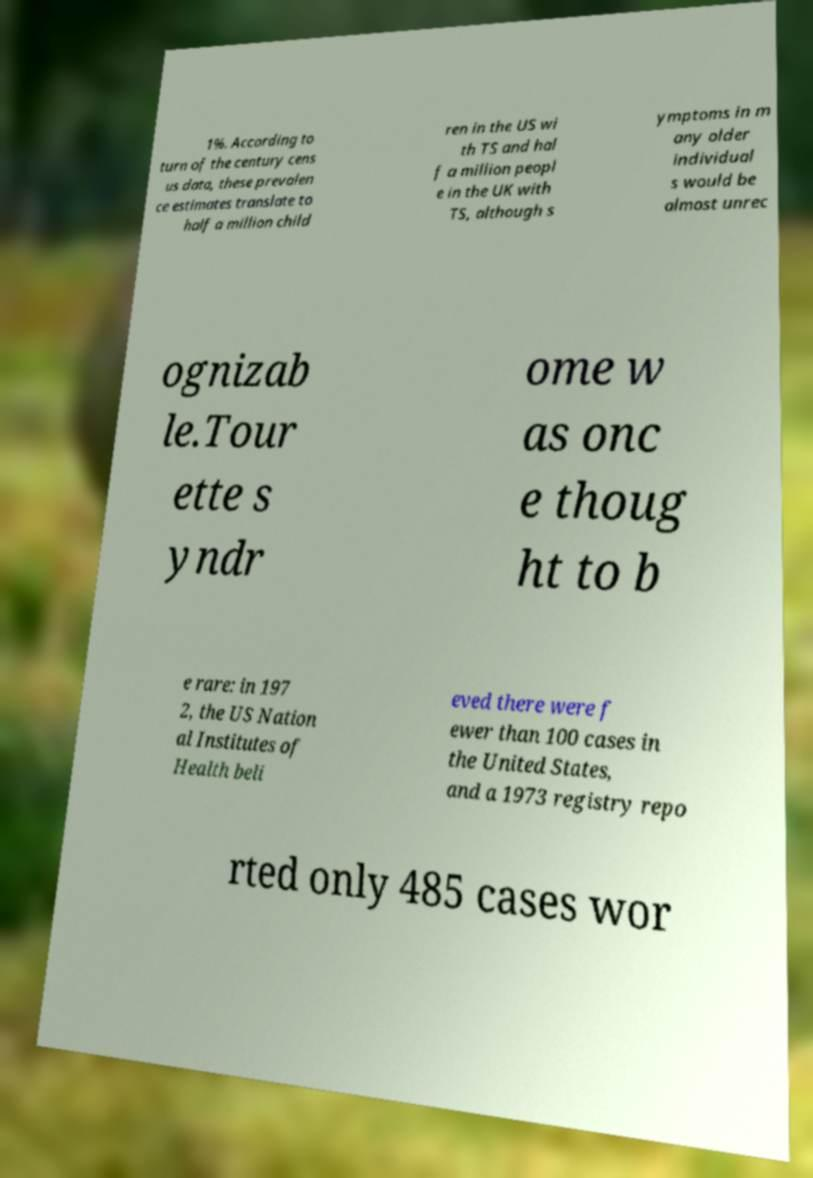Can you read and provide the text displayed in the image?This photo seems to have some interesting text. Can you extract and type it out for me? 1%. According to turn of the century cens us data, these prevalen ce estimates translate to half a million child ren in the US wi th TS and hal f a million peopl e in the UK with TS, although s ymptoms in m any older individual s would be almost unrec ognizab le.Tour ette s yndr ome w as onc e thoug ht to b e rare: in 197 2, the US Nation al Institutes of Health beli eved there were f ewer than 100 cases in the United States, and a 1973 registry repo rted only 485 cases wor 